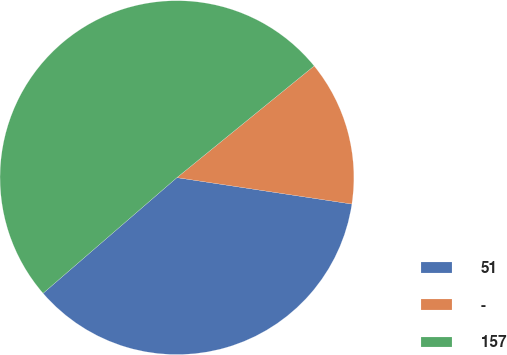<chart> <loc_0><loc_0><loc_500><loc_500><pie_chart><fcel>51<fcel>-<fcel>157<nl><fcel>36.27%<fcel>13.26%<fcel>50.47%<nl></chart> 